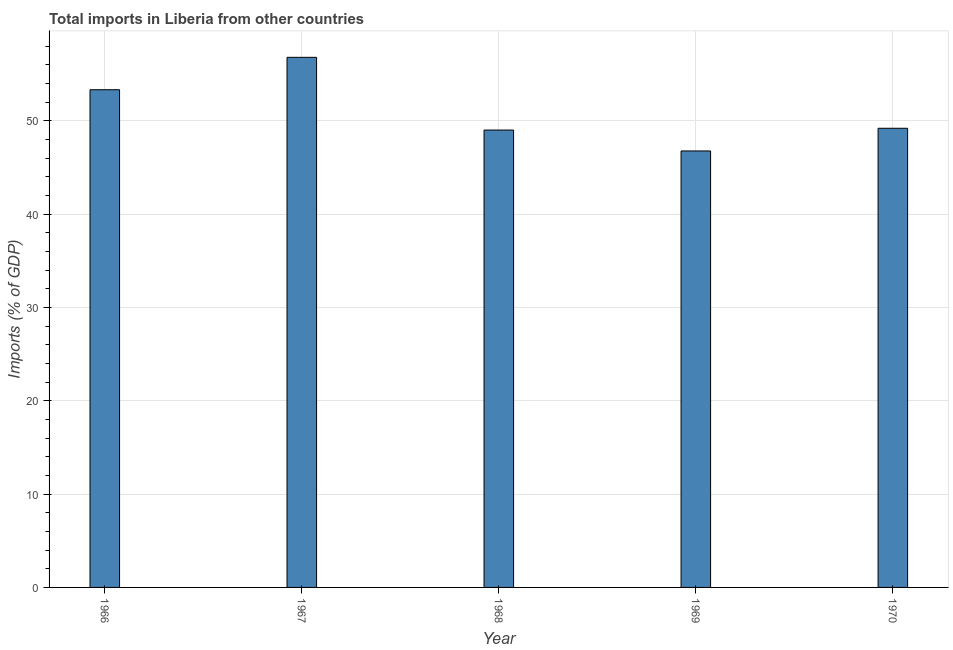Does the graph contain any zero values?
Offer a terse response. No. What is the title of the graph?
Give a very brief answer. Total imports in Liberia from other countries. What is the label or title of the Y-axis?
Provide a short and direct response. Imports (% of GDP). What is the total imports in 1969?
Provide a succinct answer. 46.78. Across all years, what is the maximum total imports?
Offer a very short reply. 56.81. Across all years, what is the minimum total imports?
Keep it short and to the point. 46.78. In which year was the total imports maximum?
Make the answer very short. 1967. In which year was the total imports minimum?
Make the answer very short. 1969. What is the sum of the total imports?
Keep it short and to the point. 255.17. What is the difference between the total imports in 1967 and 1969?
Offer a terse response. 10.03. What is the average total imports per year?
Give a very brief answer. 51.03. What is the median total imports?
Offer a very short reply. 49.21. What is the ratio of the total imports in 1966 to that in 1968?
Your answer should be compact. 1.09. Is the difference between the total imports in 1967 and 1969 greater than the difference between any two years?
Keep it short and to the point. Yes. What is the difference between the highest and the second highest total imports?
Keep it short and to the point. 3.47. Is the sum of the total imports in 1966 and 1967 greater than the maximum total imports across all years?
Provide a succinct answer. Yes. What is the difference between the highest and the lowest total imports?
Keep it short and to the point. 10.03. How many bars are there?
Make the answer very short. 5. What is the Imports (% of GDP) in 1966?
Your answer should be very brief. 53.34. What is the Imports (% of GDP) in 1967?
Offer a very short reply. 56.81. What is the Imports (% of GDP) of 1968?
Provide a short and direct response. 49.02. What is the Imports (% of GDP) in 1969?
Ensure brevity in your answer.  46.78. What is the Imports (% of GDP) in 1970?
Offer a very short reply. 49.21. What is the difference between the Imports (% of GDP) in 1966 and 1967?
Provide a short and direct response. -3.47. What is the difference between the Imports (% of GDP) in 1966 and 1968?
Offer a terse response. 4.32. What is the difference between the Imports (% of GDP) in 1966 and 1969?
Make the answer very short. 6.56. What is the difference between the Imports (% of GDP) in 1966 and 1970?
Your answer should be compact. 4.13. What is the difference between the Imports (% of GDP) in 1967 and 1968?
Your answer should be very brief. 7.79. What is the difference between the Imports (% of GDP) in 1967 and 1969?
Ensure brevity in your answer.  10.03. What is the difference between the Imports (% of GDP) in 1967 and 1970?
Your answer should be compact. 7.6. What is the difference between the Imports (% of GDP) in 1968 and 1969?
Your answer should be very brief. 2.24. What is the difference between the Imports (% of GDP) in 1968 and 1970?
Offer a terse response. -0.19. What is the difference between the Imports (% of GDP) in 1969 and 1970?
Keep it short and to the point. -2.43. What is the ratio of the Imports (% of GDP) in 1966 to that in 1967?
Keep it short and to the point. 0.94. What is the ratio of the Imports (% of GDP) in 1966 to that in 1968?
Keep it short and to the point. 1.09. What is the ratio of the Imports (% of GDP) in 1966 to that in 1969?
Provide a succinct answer. 1.14. What is the ratio of the Imports (% of GDP) in 1966 to that in 1970?
Keep it short and to the point. 1.08. What is the ratio of the Imports (% of GDP) in 1967 to that in 1968?
Provide a short and direct response. 1.16. What is the ratio of the Imports (% of GDP) in 1967 to that in 1969?
Give a very brief answer. 1.21. What is the ratio of the Imports (% of GDP) in 1967 to that in 1970?
Provide a succinct answer. 1.16. What is the ratio of the Imports (% of GDP) in 1968 to that in 1969?
Provide a succinct answer. 1.05. What is the ratio of the Imports (% of GDP) in 1968 to that in 1970?
Ensure brevity in your answer.  1. What is the ratio of the Imports (% of GDP) in 1969 to that in 1970?
Offer a terse response. 0.95. 